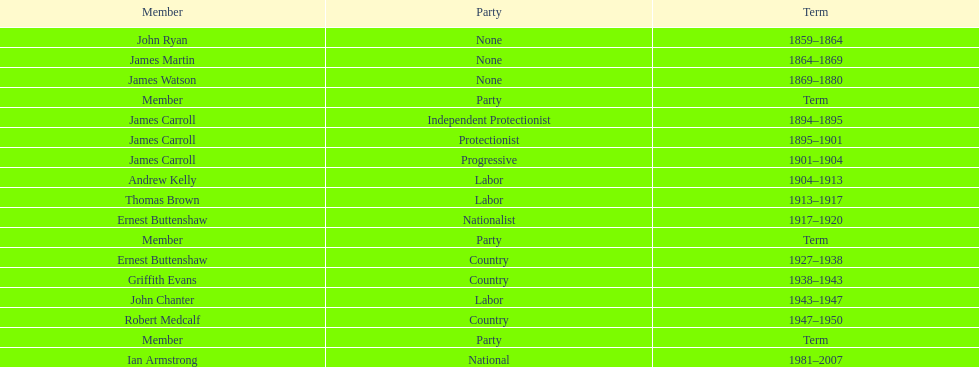Help me parse the entirety of this table. {'header': ['Member', 'Party', 'Term'], 'rows': [['John Ryan', 'None', '1859–1864'], ['James Martin', 'None', '1864–1869'], ['James Watson', 'None', '1869–1880'], ['Member', 'Party', 'Term'], ['James Carroll', 'Independent Protectionist', '1894–1895'], ['James Carroll', 'Protectionist', '1895–1901'], ['James Carroll', 'Progressive', '1901–1904'], ['Andrew Kelly', 'Labor', '1904–1913'], ['Thomas Brown', 'Labor', '1913–1917'], ['Ernest Buttenshaw', 'Nationalist', '1917–1920'], ['Member', 'Party', 'Term'], ['Ernest Buttenshaw', 'Country', '1927–1938'], ['Griffith Evans', 'Country', '1938–1943'], ['John Chanter', 'Labor', '1943–1947'], ['Robert Medcalf', 'Country', '1947–1950'], ['Member', 'Party', 'Term'], ['Ian Armstrong', 'National', '1981–2007']]} What was the existence period of the lachlan's fourth incarnation? 1981-2007. 